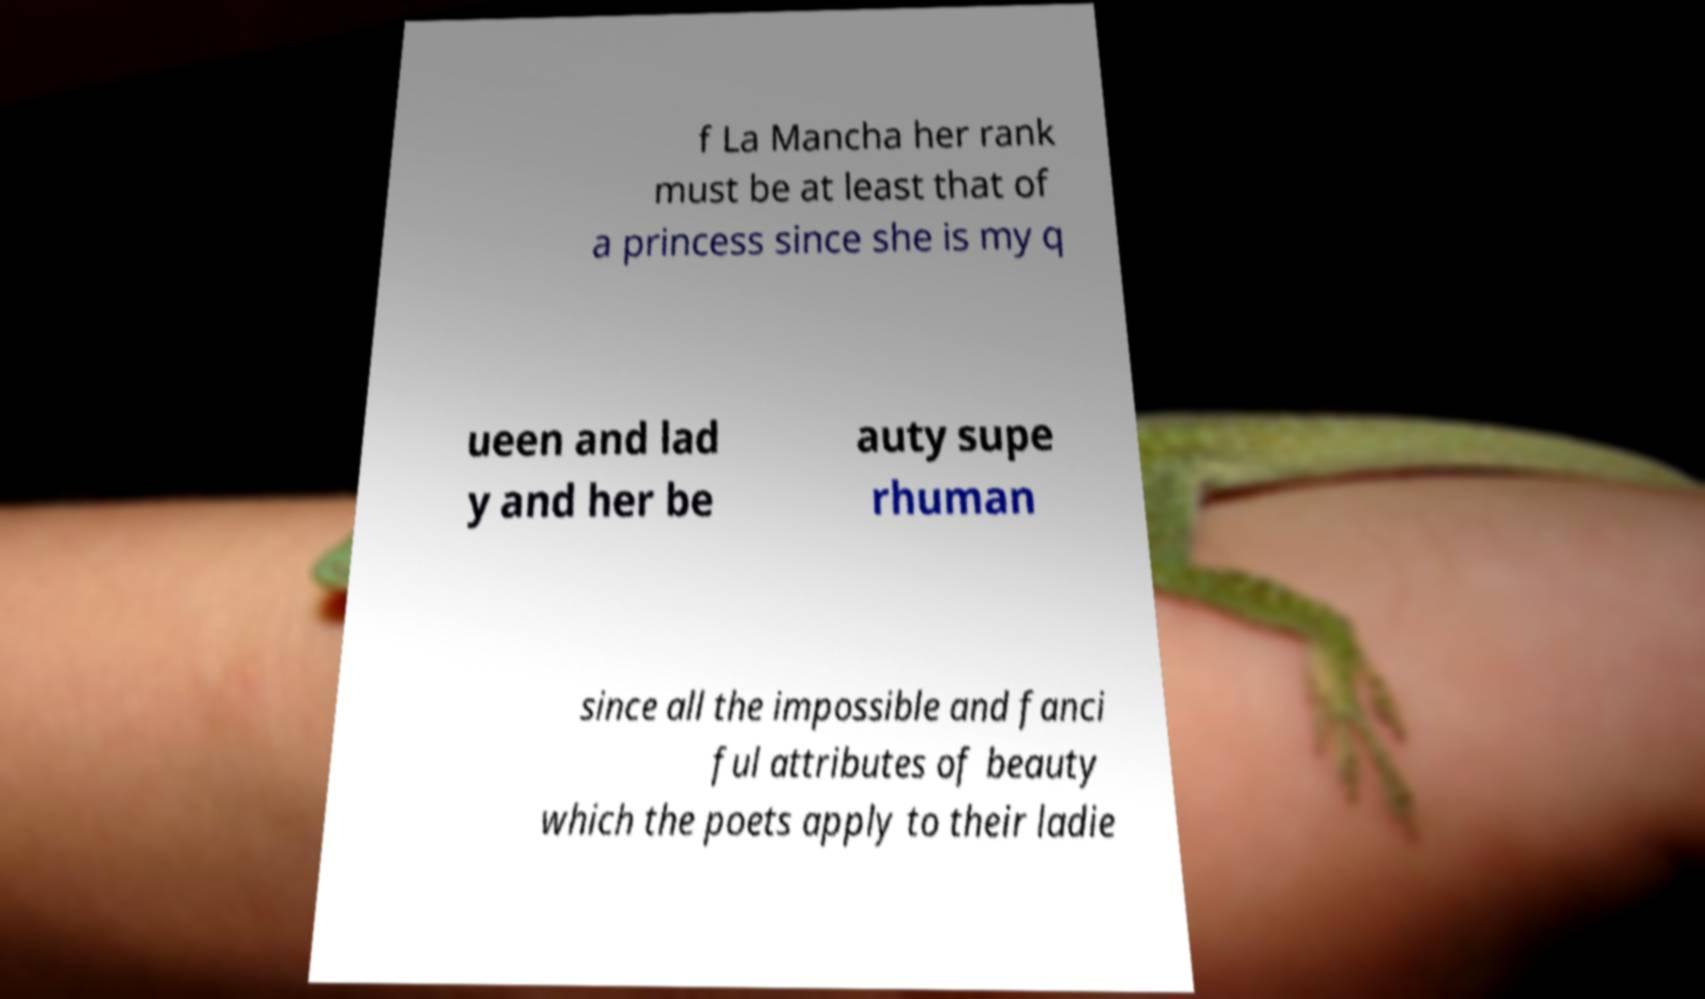For documentation purposes, I need the text within this image transcribed. Could you provide that? f La Mancha her rank must be at least that of a princess since she is my q ueen and lad y and her be auty supe rhuman since all the impossible and fanci ful attributes of beauty which the poets apply to their ladie 